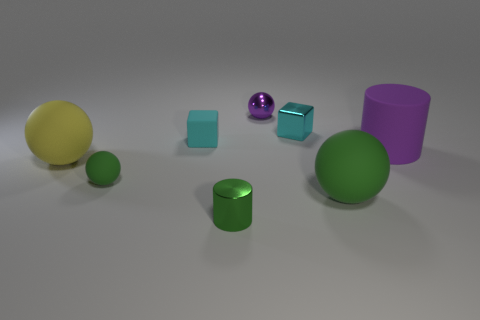Add 2 spheres. How many objects exist? 10 Subtract all cylinders. How many objects are left? 6 Add 8 tiny purple things. How many tiny purple things exist? 9 Subtract 0 brown cubes. How many objects are left? 8 Subtract all cyan matte objects. Subtract all purple rubber objects. How many objects are left? 6 Add 7 metallic spheres. How many metallic spheres are left? 8 